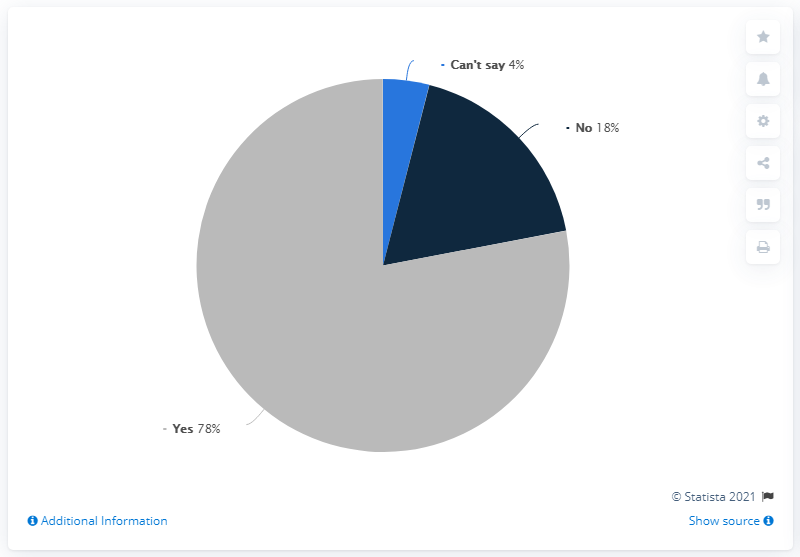Identify some key points in this picture. The ratio of the largest segment to the smallest segment is approximately 19.5. The minimum opinion plus the median of all opinions is equal to 22. 